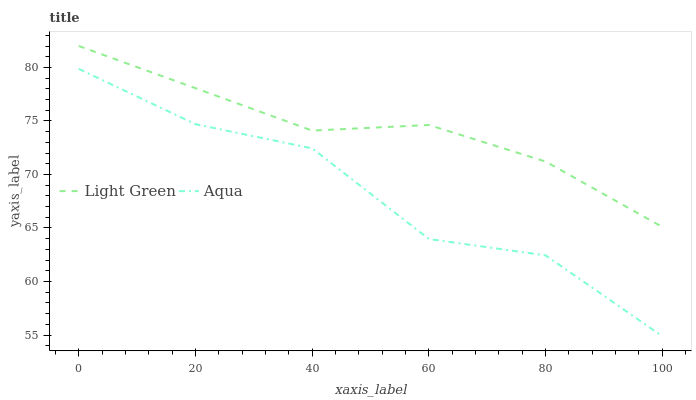Does Aqua have the minimum area under the curve?
Answer yes or no. Yes. Does Light Green have the maximum area under the curve?
Answer yes or no. Yes. Does Light Green have the minimum area under the curve?
Answer yes or no. No. Is Light Green the smoothest?
Answer yes or no. Yes. Is Aqua the roughest?
Answer yes or no. Yes. Is Light Green the roughest?
Answer yes or no. No. Does Aqua have the lowest value?
Answer yes or no. Yes. Does Light Green have the lowest value?
Answer yes or no. No. Does Light Green have the highest value?
Answer yes or no. Yes. Is Aqua less than Light Green?
Answer yes or no. Yes. Is Light Green greater than Aqua?
Answer yes or no. Yes. Does Aqua intersect Light Green?
Answer yes or no. No. 